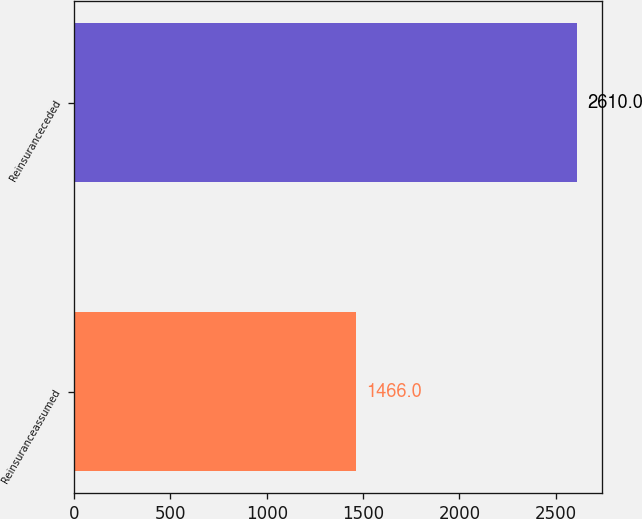Convert chart. <chart><loc_0><loc_0><loc_500><loc_500><bar_chart><fcel>Reinsuranceassumed<fcel>Reinsuranceceded<nl><fcel>1466<fcel>2610<nl></chart> 